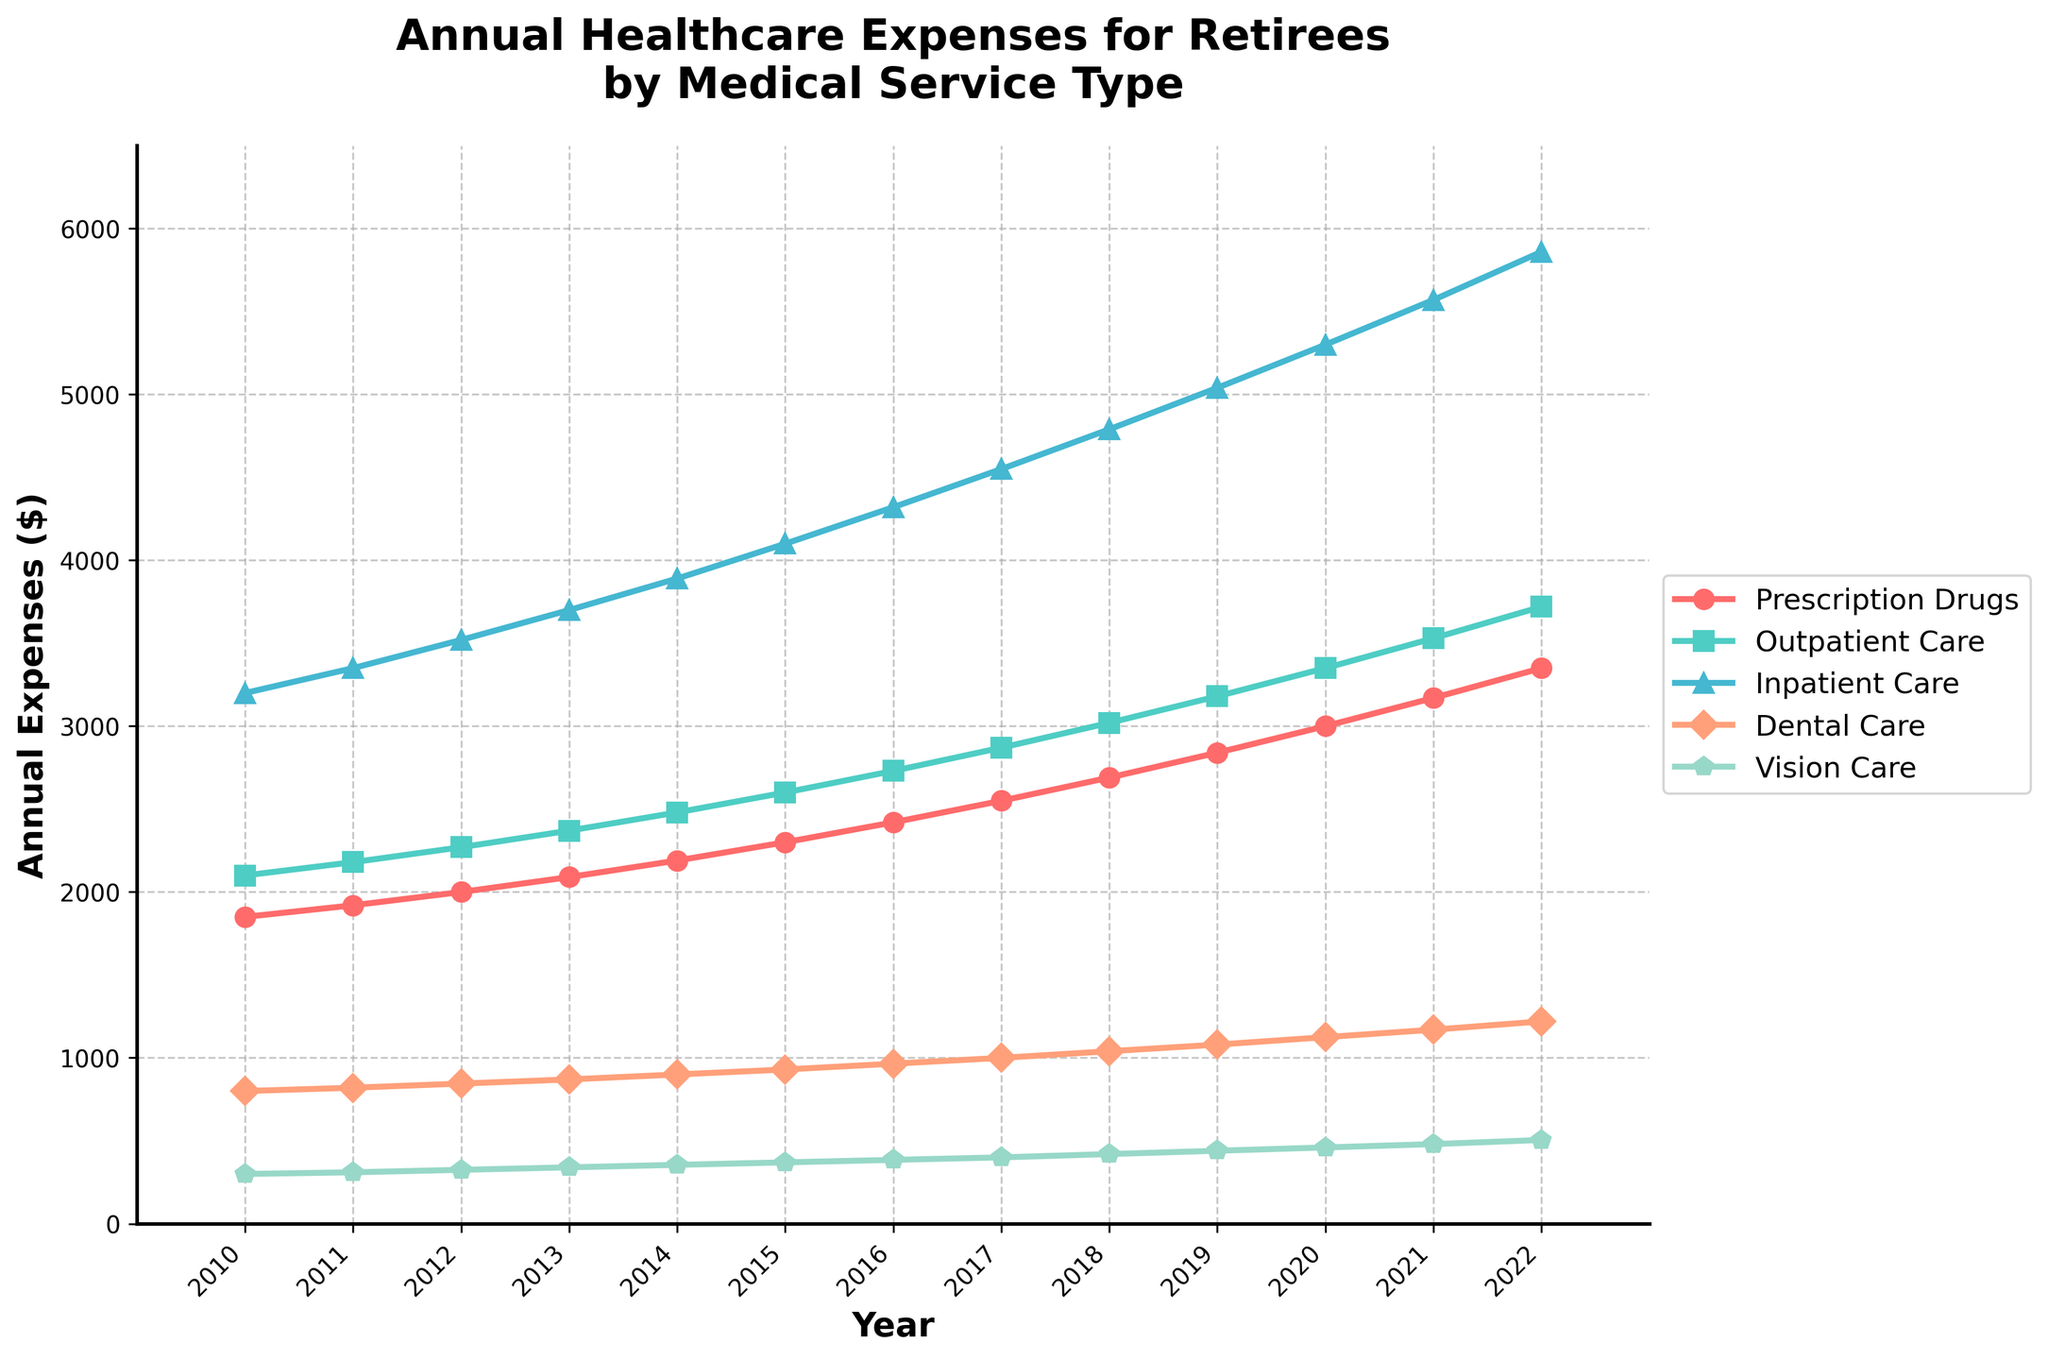Which medical service had the highest annual expense in 2022? To find out the highest expense in 2022, look for the highest data point on the y-axis corresponding to the year 2022. Compare all the services: Prescription Drugs, Outpatient Care, Inpatient Care, Dental Care, and Vision Care. Inpatient Care has the highest point in 2022.
Answer: Inpatient Care What was the annual expense for Vision Care in 2015? Locate the data point for Vision Care in 2015 along the x-axis and read the corresponding y-axis value. The point for Vision Care in 2015 is around 370 dollars.
Answer: 370 dollars How much did the annual expense for Dental Care increase from 2010 to 2022? Find the y-axis values for Dental Care for the years 2010 and 2022. The values are 800 dollars (2010) and 1220 dollars (2022). Subtract the 2010 value from the 2022 value: 1220 - 800 = 420 dollars.
Answer: 420 dollars Which medical service had the smallest annual expense in 2021? Look for the smallest data point among the services in 2021 on the y-axis. Vision Care has the lowest point when compared to Prescription Drugs, Outpatient Care, Inpatient Care, and Dental Care in 2021.
Answer: Vision Care What is the average annual expense for Prescription Drugs from 2010 to 2022? Sum the annual expenses for Prescription Drugs from 2010 to 2022, then divide by the number of years (which is 13). (1850 + 1920 + 2000 + 2090 + 2190 + 2300 + 2420 + 2550 + 2690 + 2840 + 3000 + 3170 + 3350) = 37370. Divide this by 13: 37370 / 13 ≈ 2874.62 dollars.
Answer: 2874.62 dollars By how much did the annual expense for Outpatient Care change from 2010 to 2022? Determine the y-axis values for Outpatient Care for 2010 and 2022. The values are 2100 dollars (2010) and 3720 dollars (2022). Subtract the 2010 value from the 2022 value: 3720 - 2100 = 1620 dollars.
Answer: 1620 dollars Which service had a more significant increase in expenses from 2017 to 2022, Inpatient Care or Dental Care? Determine the y-axis values for the given years for Inpatient Care and Dental Care. Inpatient Care increased from 4550 dollars (2017) to 5860 dollars (2022); difference: 5860 - 4550 = 1310 dollars. Dental Care increased from 1000 dollars (2017) to 1220 dollars (2022); difference: 1220 - 1000 = 220 dollars. Compare the differences.
Answer: Inpatient Care In which year did Prescription Drugs surpass an annual expense of 2500 dollars? Examine the data points for Prescription Drugs along the x-axis to identify the year when the expense first exceeds 2500 dollars. The data point surpasses 2500 dollars in 2017.
Answer: 2017 How much higher were the expenses for Inpatient Care compared to Vision Care in 2020? Find the y-axis values for Inpatient Care and Vision Care in 2020. Inpatient Care is 5300 dollars, and Vision Care is 460 dollars. Subtract Vision Care from Inpatient Care: 5300 - 460 = 4840 dollars.
Answer: 4840 dollars 